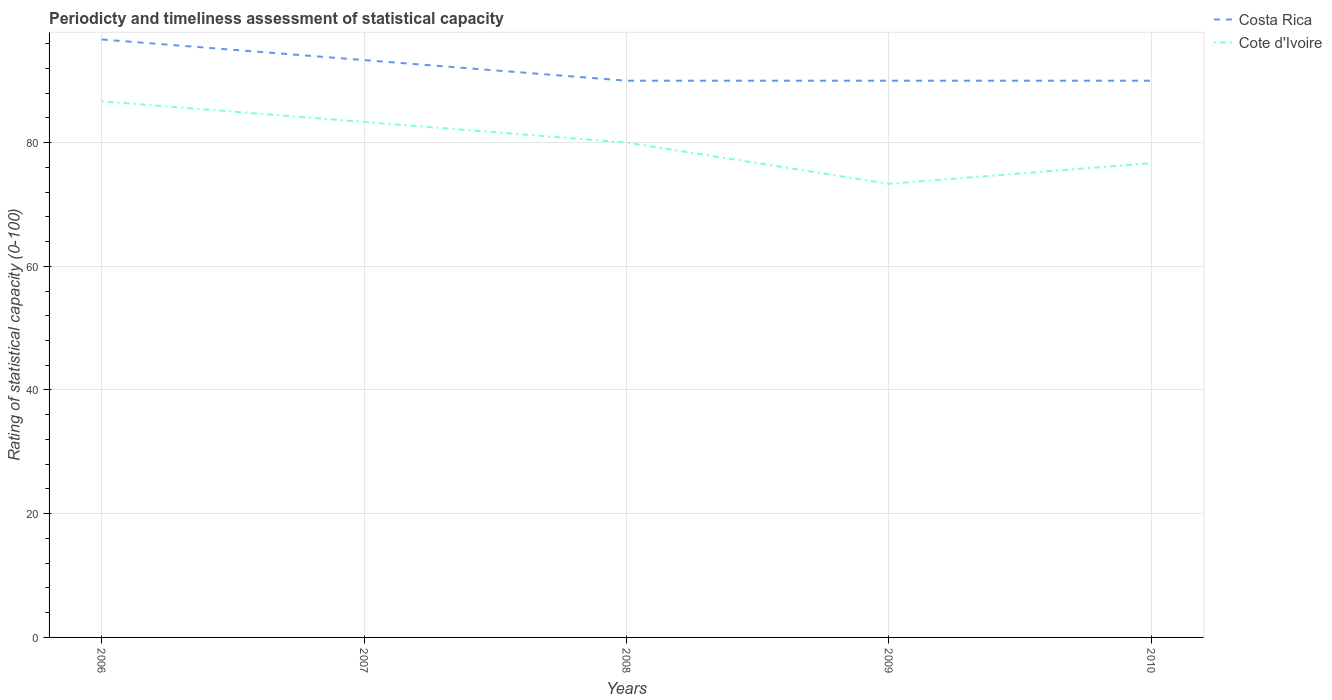How many different coloured lines are there?
Make the answer very short. 2. Does the line corresponding to Cote d'Ivoire intersect with the line corresponding to Costa Rica?
Ensure brevity in your answer.  No. Across all years, what is the maximum rating of statistical capacity in Cote d'Ivoire?
Offer a terse response. 73.33. In which year was the rating of statistical capacity in Cote d'Ivoire maximum?
Your answer should be very brief. 2009. What is the total rating of statistical capacity in Costa Rica in the graph?
Provide a succinct answer. 6.67. What is the difference between the highest and the second highest rating of statistical capacity in Costa Rica?
Your answer should be compact. 6.67. Is the rating of statistical capacity in Costa Rica strictly greater than the rating of statistical capacity in Cote d'Ivoire over the years?
Your response must be concise. No. What is the difference between two consecutive major ticks on the Y-axis?
Provide a short and direct response. 20. Does the graph contain any zero values?
Offer a terse response. No. Does the graph contain grids?
Your answer should be compact. Yes. Where does the legend appear in the graph?
Ensure brevity in your answer.  Top right. What is the title of the graph?
Offer a very short reply. Periodicty and timeliness assessment of statistical capacity. What is the label or title of the Y-axis?
Offer a very short reply. Rating of statistical capacity (0-100). What is the Rating of statistical capacity (0-100) in Costa Rica in 2006?
Give a very brief answer. 96.67. What is the Rating of statistical capacity (0-100) in Cote d'Ivoire in 2006?
Your answer should be very brief. 86.67. What is the Rating of statistical capacity (0-100) in Costa Rica in 2007?
Your answer should be very brief. 93.33. What is the Rating of statistical capacity (0-100) of Cote d'Ivoire in 2007?
Your answer should be compact. 83.33. What is the Rating of statistical capacity (0-100) of Costa Rica in 2008?
Make the answer very short. 90. What is the Rating of statistical capacity (0-100) of Cote d'Ivoire in 2008?
Your response must be concise. 80. What is the Rating of statistical capacity (0-100) in Cote d'Ivoire in 2009?
Ensure brevity in your answer.  73.33. What is the Rating of statistical capacity (0-100) in Cote d'Ivoire in 2010?
Your answer should be compact. 76.67. Across all years, what is the maximum Rating of statistical capacity (0-100) in Costa Rica?
Your answer should be very brief. 96.67. Across all years, what is the maximum Rating of statistical capacity (0-100) of Cote d'Ivoire?
Keep it short and to the point. 86.67. Across all years, what is the minimum Rating of statistical capacity (0-100) of Cote d'Ivoire?
Provide a succinct answer. 73.33. What is the total Rating of statistical capacity (0-100) in Costa Rica in the graph?
Offer a very short reply. 460. What is the difference between the Rating of statistical capacity (0-100) of Costa Rica in 2006 and that in 2009?
Provide a short and direct response. 6.67. What is the difference between the Rating of statistical capacity (0-100) in Cote d'Ivoire in 2006 and that in 2009?
Keep it short and to the point. 13.33. What is the difference between the Rating of statistical capacity (0-100) in Cote d'Ivoire in 2006 and that in 2010?
Ensure brevity in your answer.  10. What is the difference between the Rating of statistical capacity (0-100) of Costa Rica in 2009 and that in 2010?
Make the answer very short. 0. What is the difference between the Rating of statistical capacity (0-100) in Costa Rica in 2006 and the Rating of statistical capacity (0-100) in Cote d'Ivoire in 2007?
Offer a terse response. 13.33. What is the difference between the Rating of statistical capacity (0-100) of Costa Rica in 2006 and the Rating of statistical capacity (0-100) of Cote d'Ivoire in 2008?
Ensure brevity in your answer.  16.67. What is the difference between the Rating of statistical capacity (0-100) in Costa Rica in 2006 and the Rating of statistical capacity (0-100) in Cote d'Ivoire in 2009?
Ensure brevity in your answer.  23.33. What is the difference between the Rating of statistical capacity (0-100) in Costa Rica in 2007 and the Rating of statistical capacity (0-100) in Cote d'Ivoire in 2008?
Provide a short and direct response. 13.33. What is the difference between the Rating of statistical capacity (0-100) in Costa Rica in 2007 and the Rating of statistical capacity (0-100) in Cote d'Ivoire in 2010?
Offer a terse response. 16.67. What is the difference between the Rating of statistical capacity (0-100) of Costa Rica in 2008 and the Rating of statistical capacity (0-100) of Cote d'Ivoire in 2009?
Your answer should be compact. 16.67. What is the difference between the Rating of statistical capacity (0-100) of Costa Rica in 2008 and the Rating of statistical capacity (0-100) of Cote d'Ivoire in 2010?
Make the answer very short. 13.33. What is the difference between the Rating of statistical capacity (0-100) of Costa Rica in 2009 and the Rating of statistical capacity (0-100) of Cote d'Ivoire in 2010?
Ensure brevity in your answer.  13.33. What is the average Rating of statistical capacity (0-100) in Costa Rica per year?
Offer a terse response. 92. In the year 2006, what is the difference between the Rating of statistical capacity (0-100) in Costa Rica and Rating of statistical capacity (0-100) in Cote d'Ivoire?
Offer a terse response. 10. In the year 2007, what is the difference between the Rating of statistical capacity (0-100) in Costa Rica and Rating of statistical capacity (0-100) in Cote d'Ivoire?
Ensure brevity in your answer.  10. In the year 2009, what is the difference between the Rating of statistical capacity (0-100) of Costa Rica and Rating of statistical capacity (0-100) of Cote d'Ivoire?
Provide a succinct answer. 16.67. In the year 2010, what is the difference between the Rating of statistical capacity (0-100) in Costa Rica and Rating of statistical capacity (0-100) in Cote d'Ivoire?
Provide a succinct answer. 13.33. What is the ratio of the Rating of statistical capacity (0-100) of Costa Rica in 2006 to that in 2007?
Offer a terse response. 1.04. What is the ratio of the Rating of statistical capacity (0-100) in Costa Rica in 2006 to that in 2008?
Offer a terse response. 1.07. What is the ratio of the Rating of statistical capacity (0-100) of Costa Rica in 2006 to that in 2009?
Offer a terse response. 1.07. What is the ratio of the Rating of statistical capacity (0-100) in Cote d'Ivoire in 2006 to that in 2009?
Provide a short and direct response. 1.18. What is the ratio of the Rating of statistical capacity (0-100) in Costa Rica in 2006 to that in 2010?
Give a very brief answer. 1.07. What is the ratio of the Rating of statistical capacity (0-100) of Cote d'Ivoire in 2006 to that in 2010?
Make the answer very short. 1.13. What is the ratio of the Rating of statistical capacity (0-100) of Cote d'Ivoire in 2007 to that in 2008?
Offer a very short reply. 1.04. What is the ratio of the Rating of statistical capacity (0-100) of Cote d'Ivoire in 2007 to that in 2009?
Give a very brief answer. 1.14. What is the ratio of the Rating of statistical capacity (0-100) of Cote d'Ivoire in 2007 to that in 2010?
Your response must be concise. 1.09. What is the ratio of the Rating of statistical capacity (0-100) in Costa Rica in 2008 to that in 2009?
Offer a terse response. 1. What is the ratio of the Rating of statistical capacity (0-100) of Costa Rica in 2008 to that in 2010?
Offer a terse response. 1. What is the ratio of the Rating of statistical capacity (0-100) in Cote d'Ivoire in 2008 to that in 2010?
Your response must be concise. 1.04. What is the ratio of the Rating of statistical capacity (0-100) of Cote d'Ivoire in 2009 to that in 2010?
Offer a terse response. 0.96. What is the difference between the highest and the second highest Rating of statistical capacity (0-100) of Costa Rica?
Give a very brief answer. 3.33. What is the difference between the highest and the lowest Rating of statistical capacity (0-100) of Cote d'Ivoire?
Make the answer very short. 13.33. 